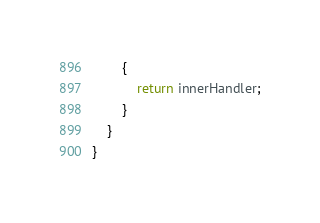Convert code to text. <code><loc_0><loc_0><loc_500><loc_500><_C#_>        {
            return innerHandler;
        }
    }
}</code> 